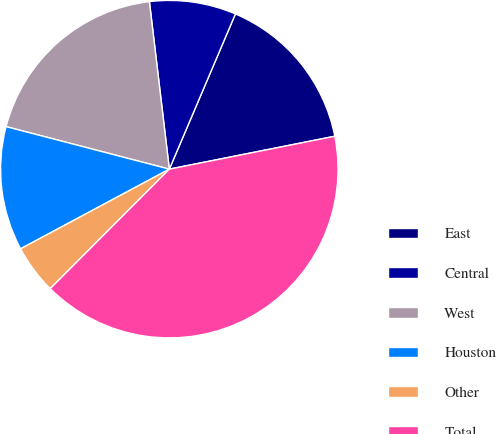Convert chart to OTSL. <chart><loc_0><loc_0><loc_500><loc_500><pie_chart><fcel>East<fcel>Central<fcel>West<fcel>Houston<fcel>Other<fcel>Total<nl><fcel>15.47%<fcel>8.29%<fcel>19.06%<fcel>11.88%<fcel>4.7%<fcel>40.6%<nl></chart> 